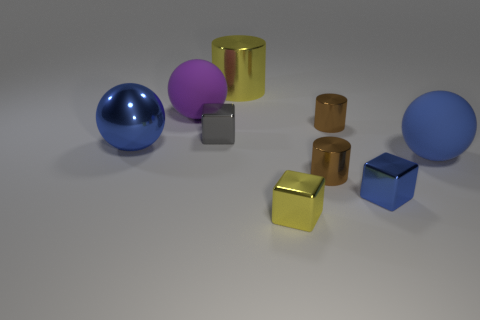Subtract all tiny gray shiny cubes. How many cubes are left? 2 Subtract all yellow cylinders. How many cylinders are left? 2 Subtract 1 balls. How many balls are left? 2 Subtract all purple cylinders. How many blue blocks are left? 1 Subtract all blue matte balls. Subtract all yellow metallic cylinders. How many objects are left? 7 Add 4 metallic balls. How many metallic balls are left? 5 Add 1 gray metal cubes. How many gray metal cubes exist? 2 Subtract 0 green cubes. How many objects are left? 9 Subtract all cylinders. How many objects are left? 6 Subtract all yellow cylinders. Subtract all gray blocks. How many cylinders are left? 2 